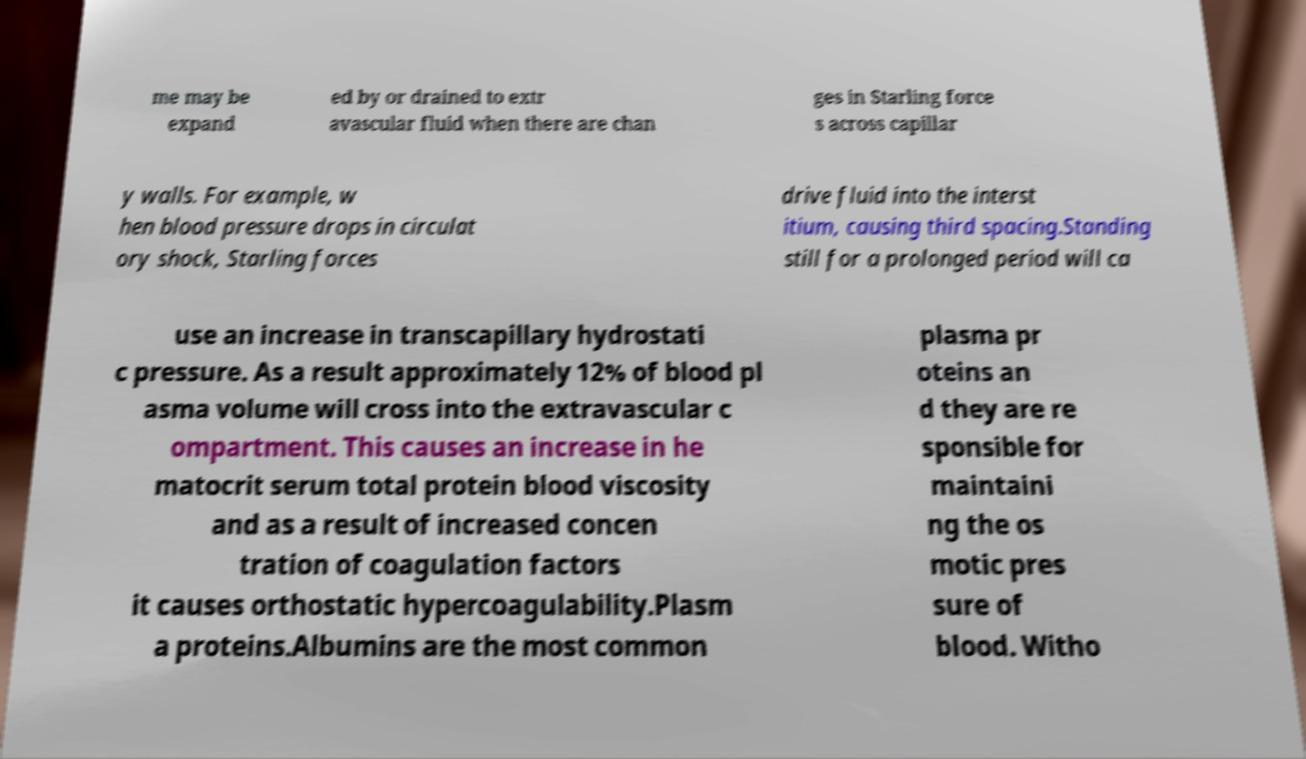What messages or text are displayed in this image? I need them in a readable, typed format. me may be expand ed by or drained to extr avascular fluid when there are chan ges in Starling force s across capillar y walls. For example, w hen blood pressure drops in circulat ory shock, Starling forces drive fluid into the interst itium, causing third spacing.Standing still for a prolonged period will ca use an increase in transcapillary hydrostati c pressure. As a result approximately 12% of blood pl asma volume will cross into the extravascular c ompartment. This causes an increase in he matocrit serum total protein blood viscosity and as a result of increased concen tration of coagulation factors it causes orthostatic hypercoagulability.Plasm a proteins.Albumins are the most common plasma pr oteins an d they are re sponsible for maintaini ng the os motic pres sure of blood. Witho 